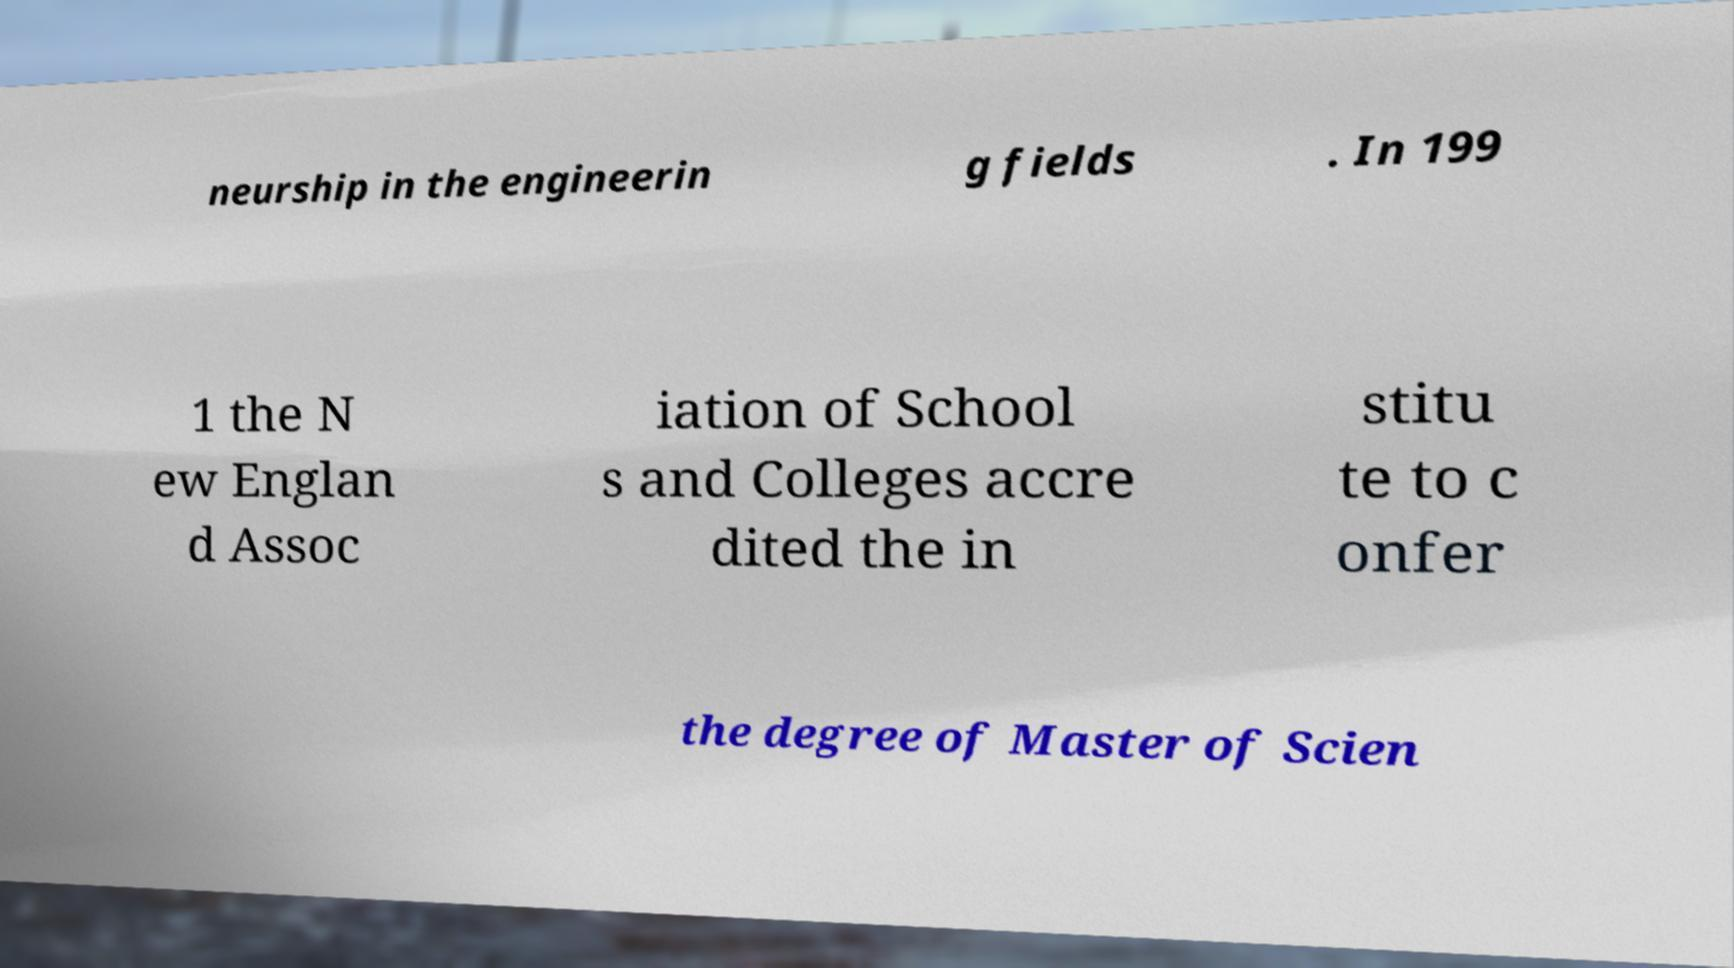There's text embedded in this image that I need extracted. Can you transcribe it verbatim? neurship in the engineerin g fields . In 199 1 the N ew Englan d Assoc iation of School s and Colleges accre dited the in stitu te to c onfer the degree of Master of Scien 